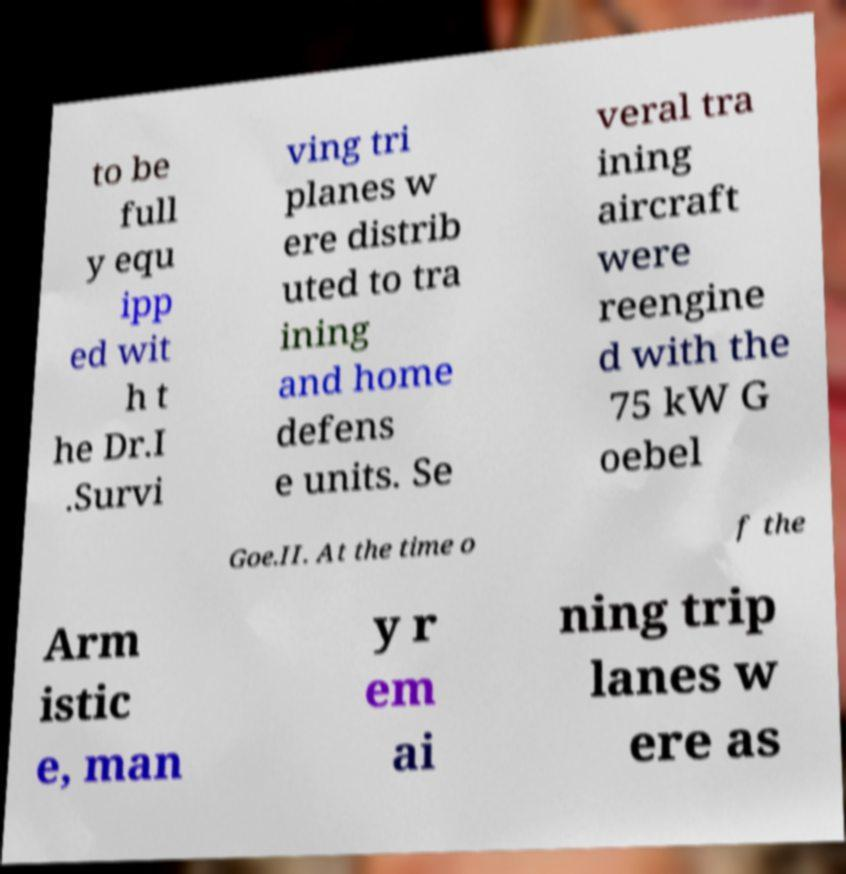For documentation purposes, I need the text within this image transcribed. Could you provide that? to be full y equ ipp ed wit h t he Dr.I .Survi ving tri planes w ere distrib uted to tra ining and home defens e units. Se veral tra ining aircraft were reengine d with the 75 kW G oebel Goe.II. At the time o f the Arm istic e, man y r em ai ning trip lanes w ere as 